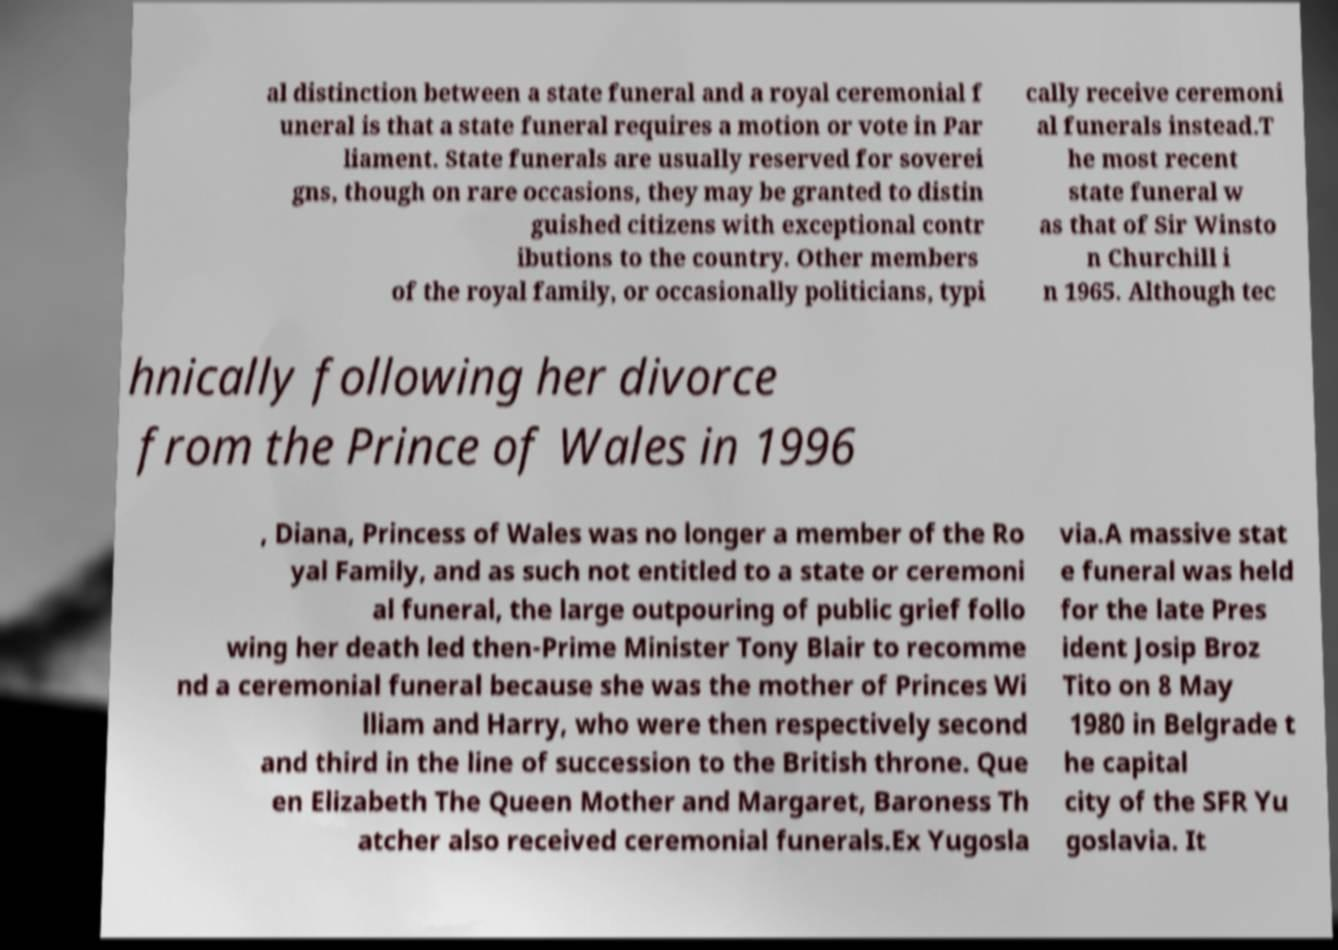There's text embedded in this image that I need extracted. Can you transcribe it verbatim? al distinction between a state funeral and a royal ceremonial f uneral is that a state funeral requires a motion or vote in Par liament. State funerals are usually reserved for soverei gns, though on rare occasions, they may be granted to distin guished citizens with exceptional contr ibutions to the country. Other members of the royal family, or occasionally politicians, typi cally receive ceremoni al funerals instead.T he most recent state funeral w as that of Sir Winsto n Churchill i n 1965. Although tec hnically following her divorce from the Prince of Wales in 1996 , Diana, Princess of Wales was no longer a member of the Ro yal Family, and as such not entitled to a state or ceremoni al funeral, the large outpouring of public grief follo wing her death led then-Prime Minister Tony Blair to recomme nd a ceremonial funeral because she was the mother of Princes Wi lliam and Harry, who were then respectively second and third in the line of succession to the British throne. Que en Elizabeth The Queen Mother and Margaret, Baroness Th atcher also received ceremonial funerals.Ex Yugosla via.A massive stat e funeral was held for the late Pres ident Josip Broz Tito on 8 May 1980 in Belgrade t he capital city of the SFR Yu goslavia. It 